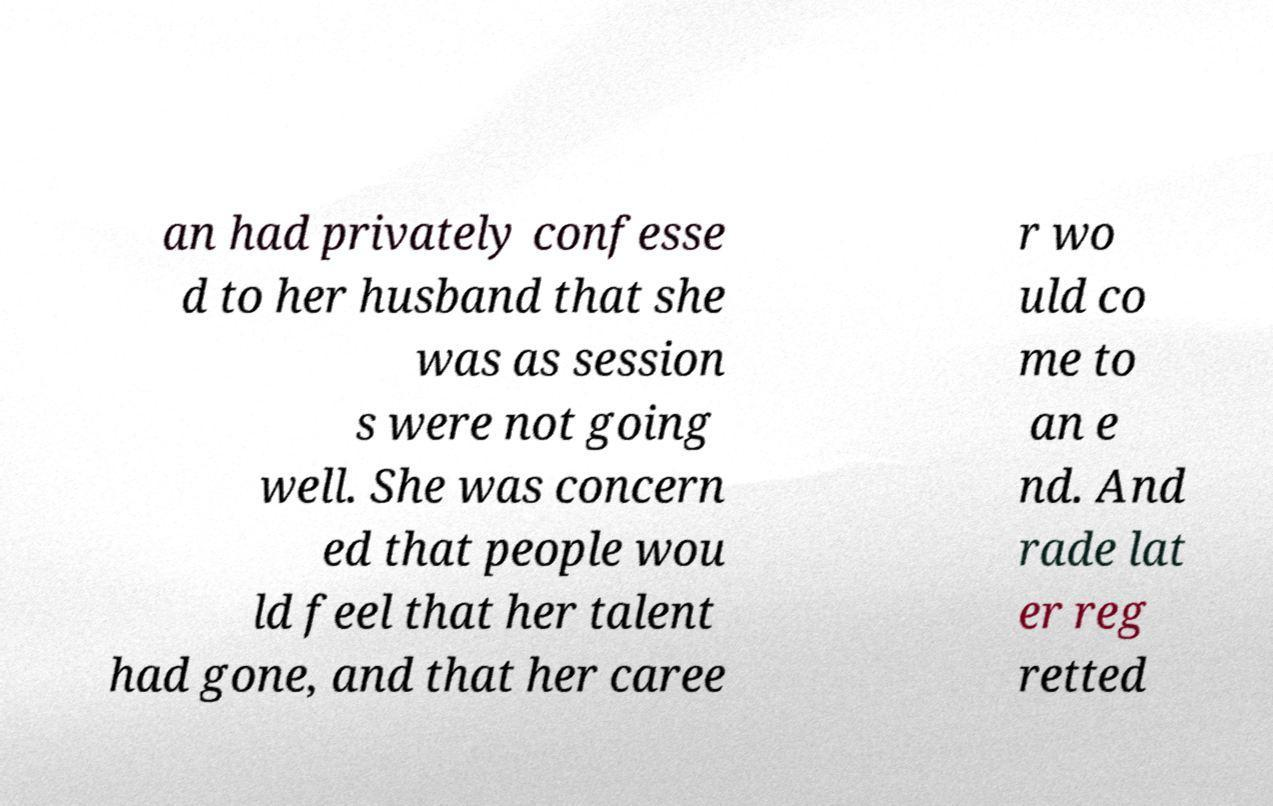What messages or text are displayed in this image? I need them in a readable, typed format. an had privately confesse d to her husband that she was as session s were not going well. She was concern ed that people wou ld feel that her talent had gone, and that her caree r wo uld co me to an e nd. And rade lat er reg retted 